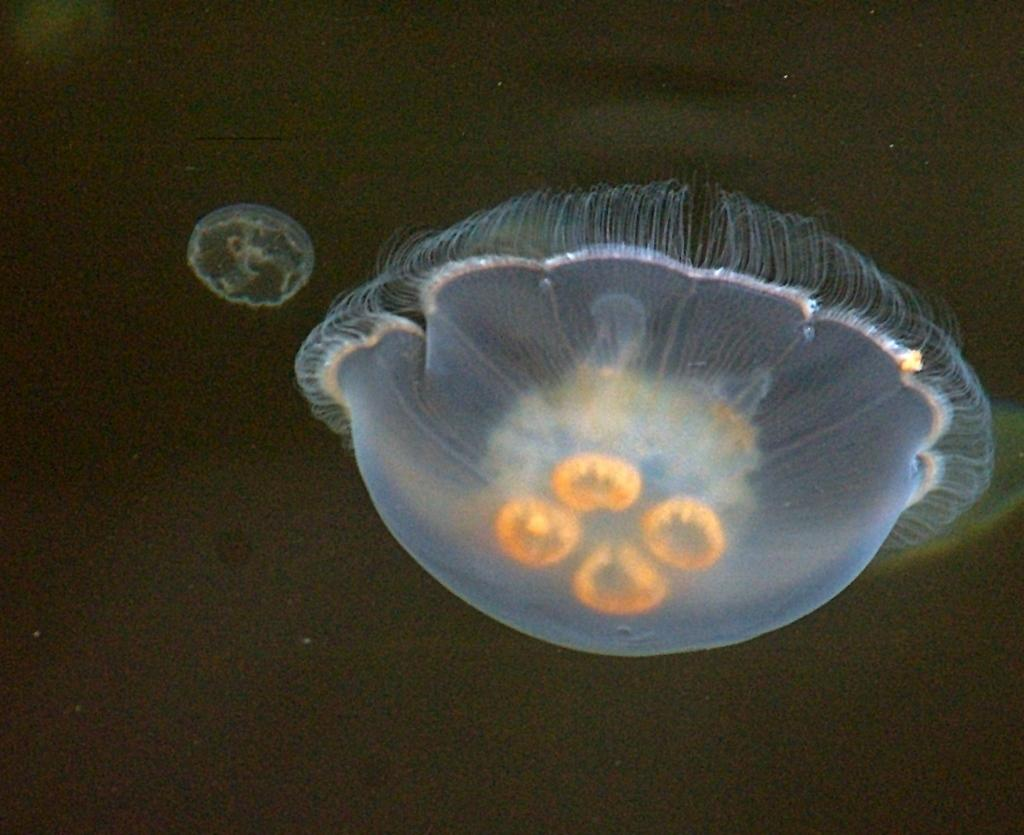What type of plants are visible in the image? There are two aquatic plants in the image. What type of skirt is the maid wearing in the image? There is no maid or skirt present in the image; it only features two aquatic plants. 